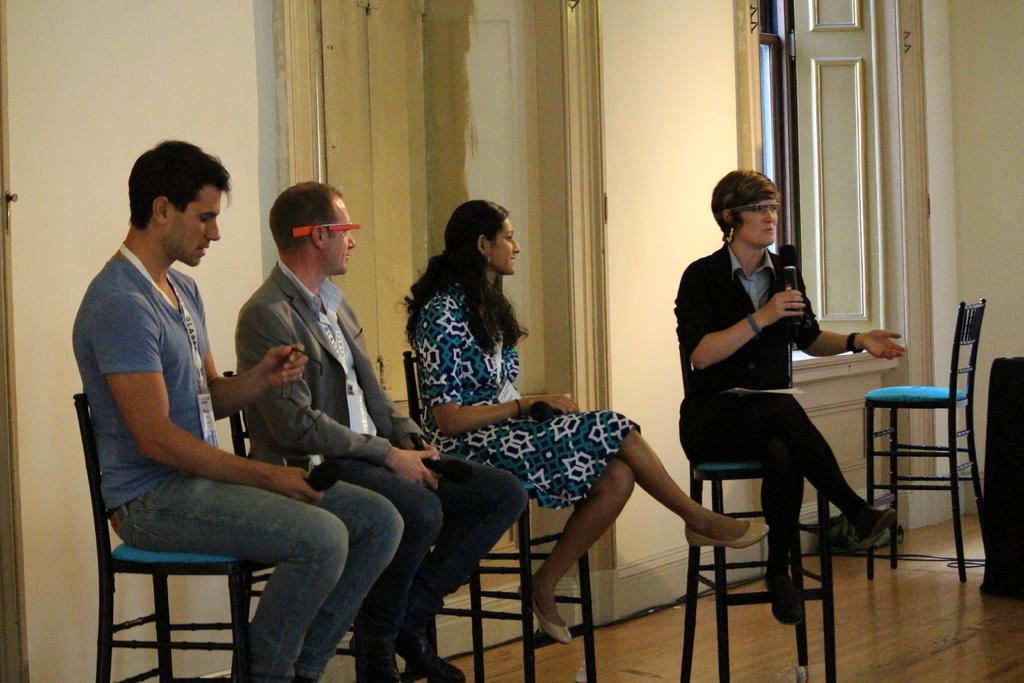What is the main subject of the image? The main subject of the image is a group of people. What are the people in the image doing? The people are seated on chairs. Can you describe the woman in the image? The woman in the image is holding a microphone and speaking. What type of fish can be seen swimming in the background of the image? There are no fish present in the image; it features a group of people seated on chairs. How many icicles are hanging from the woman's microphone in the image? There are no icicles present in the image; the woman is holding a microphone while speaking. 